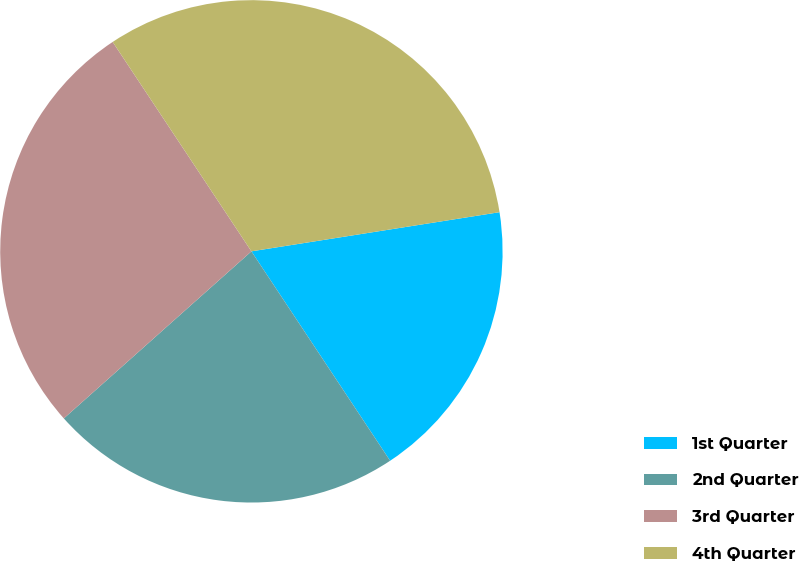Convert chart. <chart><loc_0><loc_0><loc_500><loc_500><pie_chart><fcel>1st Quarter<fcel>2nd Quarter<fcel>3rd Quarter<fcel>4th Quarter<nl><fcel>18.18%<fcel>22.73%<fcel>27.27%<fcel>31.82%<nl></chart> 